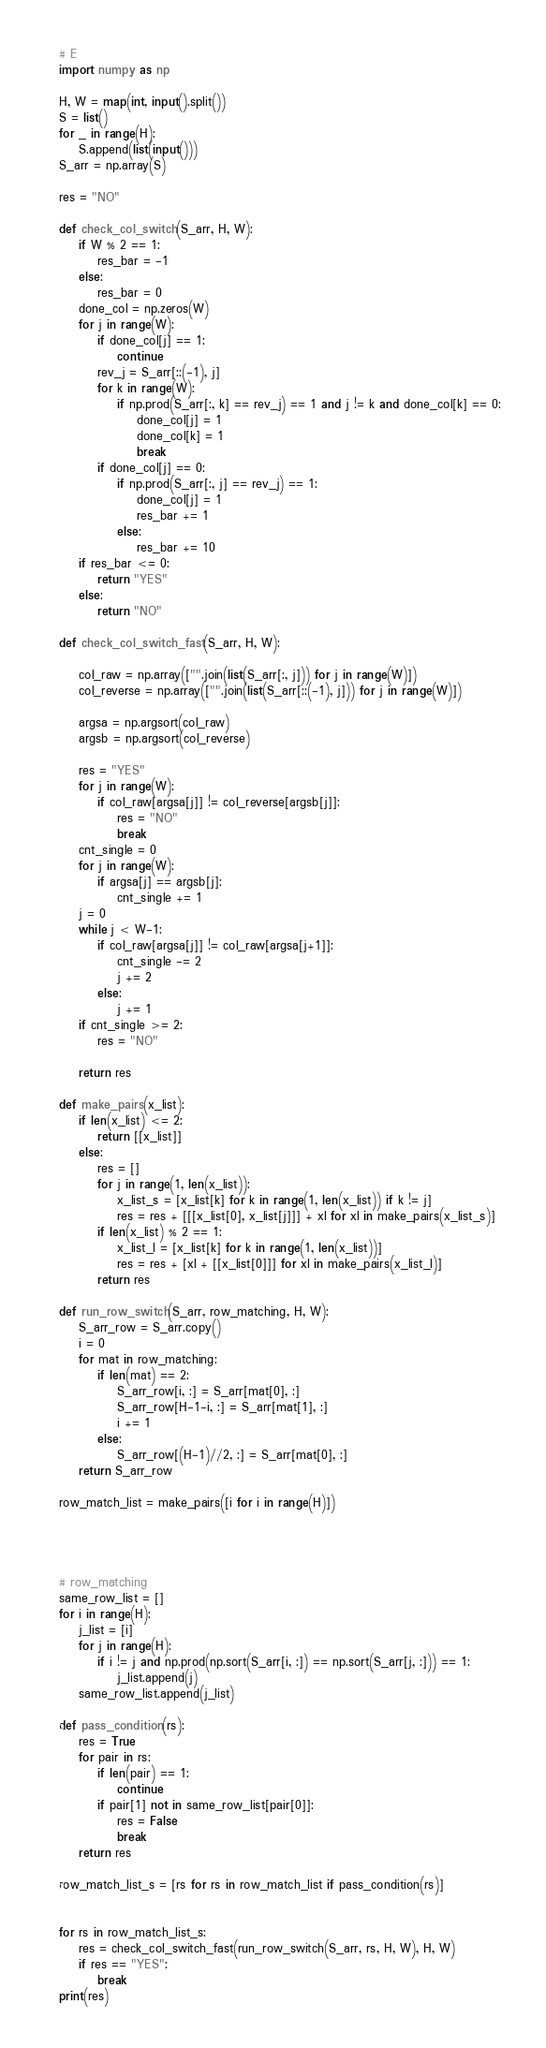<code> <loc_0><loc_0><loc_500><loc_500><_Python_># E
import numpy as np

H, W = map(int, input().split())
S = list()
for _ in range(H):
    S.append(list(input()))
S_arr = np.array(S)

res = "NO"

def check_col_switch(S_arr, H, W):
    if W % 2 == 1:
        res_bar = -1
    else:
        res_bar = 0
    done_col = np.zeros(W)
    for j in range(W):
        if done_col[j] == 1:
            continue
        rev_j = S_arr[::(-1), j]
        for k in range(W):
            if np.prod(S_arr[:, k] == rev_j) == 1 and j != k and done_col[k] == 0:
                done_col[j] = 1
                done_col[k] = 1
                break
        if done_col[j] == 0:
            if np.prod(S_arr[:, j] == rev_j) == 1:
                done_col[j] = 1
                res_bar += 1
            else:
                res_bar += 10
    if res_bar <= 0:
        return "YES"
    else:
        return "NO"
    
def check_col_switch_fast(S_arr, H, W):
    
    col_raw = np.array(["".join(list(S_arr[:, j])) for j in range(W)])
    col_reverse = np.array(["".join(list(S_arr[::(-1), j])) for j in range(W)])
    
    argsa = np.argsort(col_raw)
    argsb = np.argsort(col_reverse)
    
    res = "YES"
    for j in range(W):
        if col_raw[argsa[j]] != col_reverse[argsb[j]]:
            res = "NO"
            break
    cnt_single = 0
    for j in range(W):
        if argsa[j] == argsb[j]:
            cnt_single += 1
    j = 0
    while j < W-1:
        if col_raw[argsa[j]] != col_raw[argsa[j+1]]:
            cnt_single -= 2
            j += 2
        else:
            j += 1
    if cnt_single >= 2:
        res = "NO"
    
    return res
    
def make_pairs(x_list):
    if len(x_list) <= 2:
        return [[x_list]]
    else:
        res = []
        for j in range(1, len(x_list)):
            x_list_s = [x_list[k] for k in range(1, len(x_list)) if k != j]
            res = res + [[[x_list[0], x_list[j]]] + xl for xl in make_pairs(x_list_s)]
        if len(x_list) % 2 == 1:
            x_list_l = [x_list[k] for k in range(1, len(x_list))]
            res = res + [xl + [[x_list[0]]] for xl in make_pairs(x_list_l)]
        return res
    
def run_row_switch(S_arr, row_matching, H, W):
    S_arr_row = S_arr.copy()
    i = 0
    for mat in row_matching:
        if len(mat) == 2:
            S_arr_row[i, :] = S_arr[mat[0], :]
            S_arr_row[H-1-i, :] = S_arr[mat[1], :]
            i += 1
        else:
            S_arr_row[(H-1)//2, :] = S_arr[mat[0], :]
    return S_arr_row
            
row_match_list = make_pairs([i for i in range(H)])


    

# row_matching
same_row_list = []
for i in range(H):
    j_list = [i]
    for j in range(H):
        if i != j and np.prod(np.sort(S_arr[i, :]) == np.sort(S_arr[j, :])) == 1:
            j_list.append(j)
    same_row_list.append(j_list)
    
def pass_condition(rs):
    res = True
    for pair in rs:
        if len(pair) == 1:
            continue
        if pair[1] not in same_row_list[pair[0]]:
            res = False
            break
    return res

row_match_list_s = [rs for rs in row_match_list if pass_condition(rs)]


for rs in row_match_list_s:
    res = check_col_switch_fast(run_row_switch(S_arr, rs, H, W), H, W)
    if res == "YES":
        break
print(res)</code> 